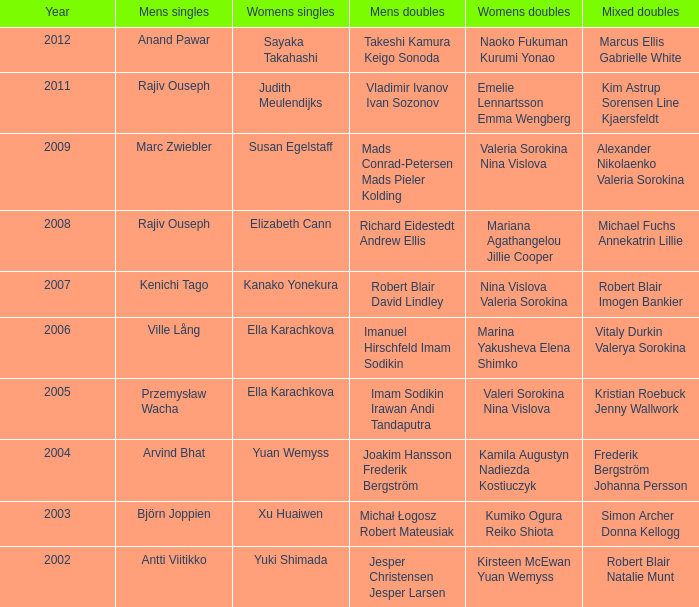What does the women's singles category for marcus ellis and gabrielle white represent? Sayaka Takahashi. 